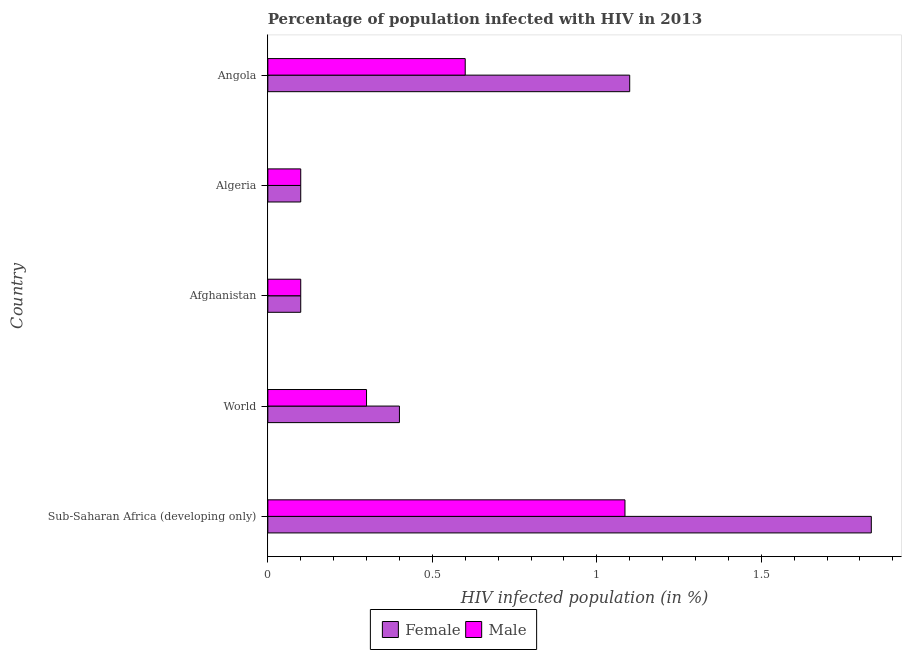How many different coloured bars are there?
Keep it short and to the point. 2. Are the number of bars per tick equal to the number of legend labels?
Provide a succinct answer. Yes. Are the number of bars on each tick of the Y-axis equal?
Ensure brevity in your answer.  Yes. How many bars are there on the 4th tick from the bottom?
Offer a very short reply. 2. In how many cases, is the number of bars for a given country not equal to the number of legend labels?
Your response must be concise. 0. Across all countries, what is the maximum percentage of females who are infected with hiv?
Offer a very short reply. 1.83. In which country was the percentage of males who are infected with hiv maximum?
Keep it short and to the point. Sub-Saharan Africa (developing only). In which country was the percentage of males who are infected with hiv minimum?
Your answer should be compact. Afghanistan. What is the total percentage of males who are infected with hiv in the graph?
Make the answer very short. 2.19. What is the difference between the percentage of females who are infected with hiv in Angola and that in Sub-Saharan Africa (developing only)?
Provide a succinct answer. -0.73. What is the difference between the percentage of females who are infected with hiv in Sub-Saharan Africa (developing only) and the percentage of males who are infected with hiv in Algeria?
Provide a short and direct response. 1.73. What is the average percentage of males who are infected with hiv per country?
Your answer should be compact. 0.44. What is the ratio of the percentage of males who are infected with hiv in Afghanistan to that in Sub-Saharan Africa (developing only)?
Offer a terse response. 0.09. Is the percentage of males who are infected with hiv in Afghanistan less than that in World?
Provide a succinct answer. Yes. What is the difference between the highest and the second highest percentage of females who are infected with hiv?
Offer a terse response. 0.73. In how many countries, is the percentage of males who are infected with hiv greater than the average percentage of males who are infected with hiv taken over all countries?
Your answer should be very brief. 2. Is the sum of the percentage of males who are infected with hiv in Afghanistan and Sub-Saharan Africa (developing only) greater than the maximum percentage of females who are infected with hiv across all countries?
Ensure brevity in your answer.  No. What does the 1st bar from the bottom in Angola represents?
Your answer should be very brief. Female. What is the difference between two consecutive major ticks on the X-axis?
Keep it short and to the point. 0.5. Does the graph contain grids?
Your answer should be very brief. No. How are the legend labels stacked?
Offer a very short reply. Horizontal. What is the title of the graph?
Make the answer very short. Percentage of population infected with HIV in 2013. Does "Services" appear as one of the legend labels in the graph?
Your response must be concise. No. What is the label or title of the X-axis?
Keep it short and to the point. HIV infected population (in %). What is the label or title of the Y-axis?
Your response must be concise. Country. What is the HIV infected population (in %) of Female in Sub-Saharan Africa (developing only)?
Provide a short and direct response. 1.83. What is the HIV infected population (in %) in Male in Sub-Saharan Africa (developing only)?
Keep it short and to the point. 1.09. What is the HIV infected population (in %) in Male in World?
Ensure brevity in your answer.  0.3. What is the HIV infected population (in %) of Male in Algeria?
Offer a terse response. 0.1. Across all countries, what is the maximum HIV infected population (in %) of Female?
Offer a terse response. 1.83. Across all countries, what is the maximum HIV infected population (in %) of Male?
Make the answer very short. 1.09. Across all countries, what is the minimum HIV infected population (in %) of Female?
Offer a terse response. 0.1. Across all countries, what is the minimum HIV infected population (in %) in Male?
Ensure brevity in your answer.  0.1. What is the total HIV infected population (in %) in Female in the graph?
Provide a succinct answer. 3.53. What is the total HIV infected population (in %) in Male in the graph?
Your answer should be compact. 2.19. What is the difference between the HIV infected population (in %) in Female in Sub-Saharan Africa (developing only) and that in World?
Keep it short and to the point. 1.43. What is the difference between the HIV infected population (in %) in Male in Sub-Saharan Africa (developing only) and that in World?
Keep it short and to the point. 0.79. What is the difference between the HIV infected population (in %) of Female in Sub-Saharan Africa (developing only) and that in Afghanistan?
Offer a very short reply. 1.73. What is the difference between the HIV infected population (in %) of Male in Sub-Saharan Africa (developing only) and that in Afghanistan?
Give a very brief answer. 0.99. What is the difference between the HIV infected population (in %) of Female in Sub-Saharan Africa (developing only) and that in Algeria?
Your answer should be very brief. 1.73. What is the difference between the HIV infected population (in %) in Male in Sub-Saharan Africa (developing only) and that in Algeria?
Your answer should be compact. 0.99. What is the difference between the HIV infected population (in %) of Female in Sub-Saharan Africa (developing only) and that in Angola?
Provide a succinct answer. 0.73. What is the difference between the HIV infected population (in %) of Male in Sub-Saharan Africa (developing only) and that in Angola?
Give a very brief answer. 0.49. What is the difference between the HIV infected population (in %) of Male in World and that in Afghanistan?
Your response must be concise. 0.2. What is the difference between the HIV infected population (in %) of Female in World and that in Algeria?
Offer a terse response. 0.3. What is the difference between the HIV infected population (in %) of Male in World and that in Algeria?
Your answer should be very brief. 0.2. What is the difference between the HIV infected population (in %) in Male in World and that in Angola?
Ensure brevity in your answer.  -0.3. What is the difference between the HIV infected population (in %) in Female in Afghanistan and that in Algeria?
Your answer should be very brief. 0. What is the difference between the HIV infected population (in %) of Female in Afghanistan and that in Angola?
Offer a terse response. -1. What is the difference between the HIV infected population (in %) of Male in Afghanistan and that in Angola?
Keep it short and to the point. -0.5. What is the difference between the HIV infected population (in %) of Female in Sub-Saharan Africa (developing only) and the HIV infected population (in %) of Male in World?
Your response must be concise. 1.53. What is the difference between the HIV infected population (in %) in Female in Sub-Saharan Africa (developing only) and the HIV infected population (in %) in Male in Afghanistan?
Your answer should be compact. 1.73. What is the difference between the HIV infected population (in %) of Female in Sub-Saharan Africa (developing only) and the HIV infected population (in %) of Male in Algeria?
Your answer should be compact. 1.73. What is the difference between the HIV infected population (in %) of Female in Sub-Saharan Africa (developing only) and the HIV infected population (in %) of Male in Angola?
Give a very brief answer. 1.23. What is the difference between the HIV infected population (in %) of Female in World and the HIV infected population (in %) of Male in Afghanistan?
Provide a short and direct response. 0.3. What is the difference between the HIV infected population (in %) of Female in World and the HIV infected population (in %) of Male in Angola?
Your response must be concise. -0.2. What is the difference between the HIV infected population (in %) of Female in Afghanistan and the HIV infected population (in %) of Male in Angola?
Your answer should be compact. -0.5. What is the average HIV infected population (in %) in Female per country?
Make the answer very short. 0.71. What is the average HIV infected population (in %) of Male per country?
Your answer should be compact. 0.44. What is the difference between the HIV infected population (in %) in Female and HIV infected population (in %) in Male in Sub-Saharan Africa (developing only)?
Offer a terse response. 0.75. What is the difference between the HIV infected population (in %) of Female and HIV infected population (in %) of Male in World?
Offer a terse response. 0.1. What is the difference between the HIV infected population (in %) of Female and HIV infected population (in %) of Male in Angola?
Offer a very short reply. 0.5. What is the ratio of the HIV infected population (in %) in Female in Sub-Saharan Africa (developing only) to that in World?
Make the answer very short. 4.59. What is the ratio of the HIV infected population (in %) in Male in Sub-Saharan Africa (developing only) to that in World?
Make the answer very short. 3.62. What is the ratio of the HIV infected population (in %) of Female in Sub-Saharan Africa (developing only) to that in Afghanistan?
Your response must be concise. 18.34. What is the ratio of the HIV infected population (in %) in Male in Sub-Saharan Africa (developing only) to that in Afghanistan?
Ensure brevity in your answer.  10.86. What is the ratio of the HIV infected population (in %) in Female in Sub-Saharan Africa (developing only) to that in Algeria?
Your response must be concise. 18.34. What is the ratio of the HIV infected population (in %) in Male in Sub-Saharan Africa (developing only) to that in Algeria?
Offer a very short reply. 10.86. What is the ratio of the HIV infected population (in %) of Female in Sub-Saharan Africa (developing only) to that in Angola?
Give a very brief answer. 1.67. What is the ratio of the HIV infected population (in %) of Male in Sub-Saharan Africa (developing only) to that in Angola?
Offer a terse response. 1.81. What is the ratio of the HIV infected population (in %) of Male in World to that in Algeria?
Your response must be concise. 3. What is the ratio of the HIV infected population (in %) in Female in World to that in Angola?
Provide a short and direct response. 0.36. What is the ratio of the HIV infected population (in %) of Male in World to that in Angola?
Give a very brief answer. 0.5. What is the ratio of the HIV infected population (in %) of Female in Afghanistan to that in Angola?
Provide a succinct answer. 0.09. What is the ratio of the HIV infected population (in %) of Male in Afghanistan to that in Angola?
Your answer should be compact. 0.17. What is the ratio of the HIV infected population (in %) of Female in Algeria to that in Angola?
Provide a succinct answer. 0.09. What is the difference between the highest and the second highest HIV infected population (in %) of Female?
Your answer should be compact. 0.73. What is the difference between the highest and the second highest HIV infected population (in %) of Male?
Make the answer very short. 0.49. What is the difference between the highest and the lowest HIV infected population (in %) of Female?
Offer a terse response. 1.73. What is the difference between the highest and the lowest HIV infected population (in %) in Male?
Make the answer very short. 0.99. 